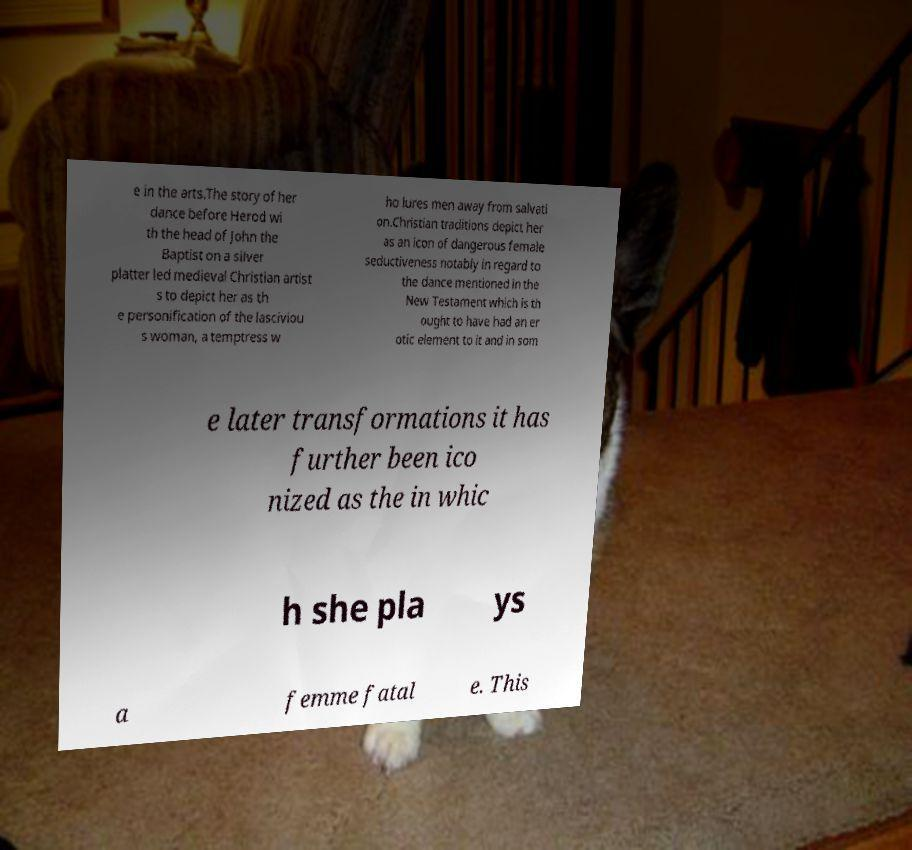What messages or text are displayed in this image? I need them in a readable, typed format. e in the arts.The story of her dance before Herod wi th the head of John the Baptist on a silver platter led medieval Christian artist s to depict her as th e personification of the lasciviou s woman, a temptress w ho lures men away from salvati on.Christian traditions depict her as an icon of dangerous female seductiveness notably in regard to the dance mentioned in the New Testament which is th ought to have had an er otic element to it and in som e later transformations it has further been ico nized as the in whic h she pla ys a femme fatal e. This 